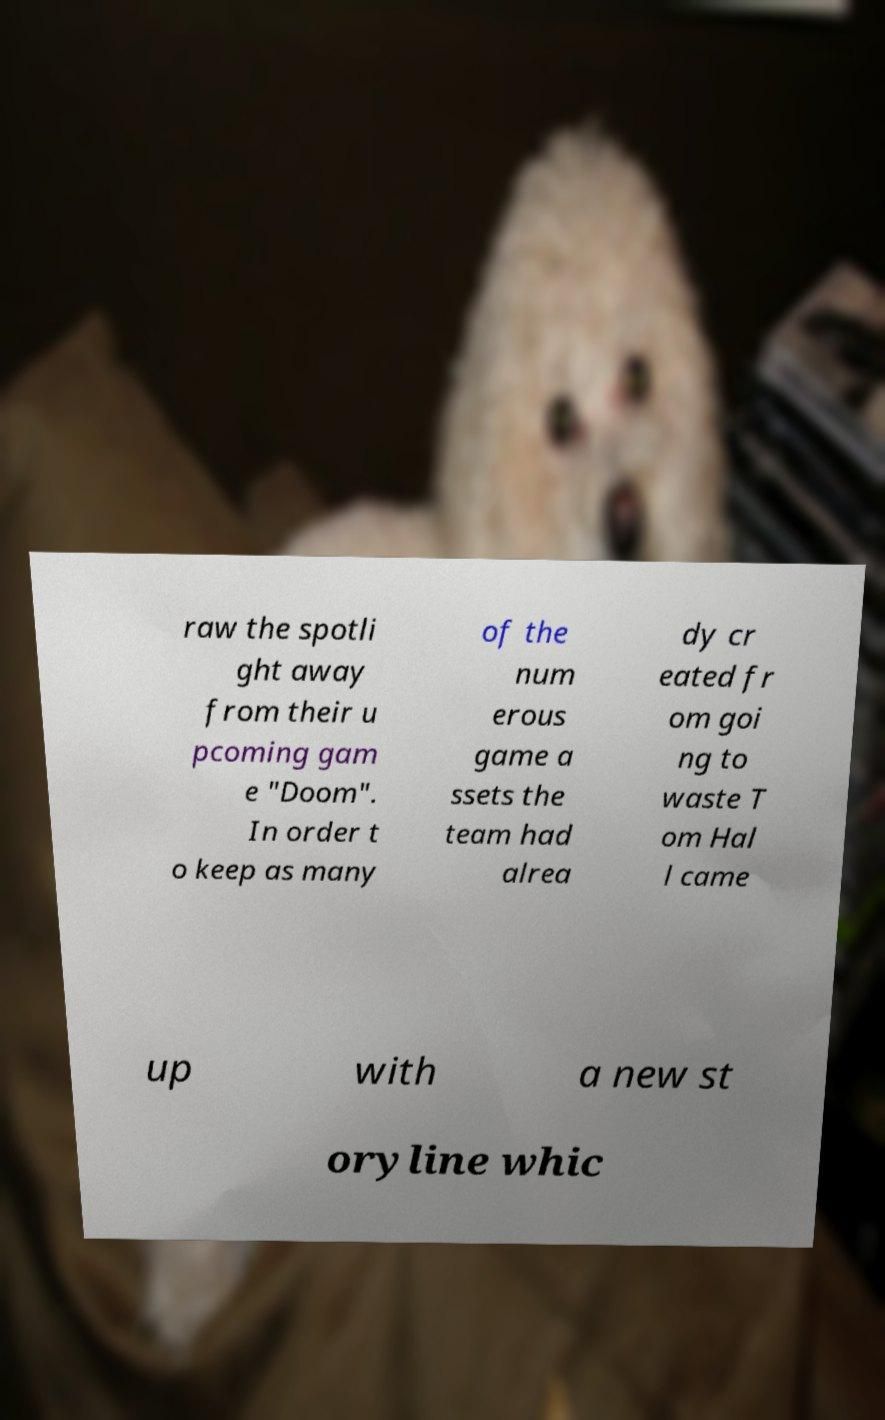I need the written content from this picture converted into text. Can you do that? raw the spotli ght away from their u pcoming gam e "Doom". In order t o keep as many of the num erous game a ssets the team had alrea dy cr eated fr om goi ng to waste T om Hal l came up with a new st oryline whic 